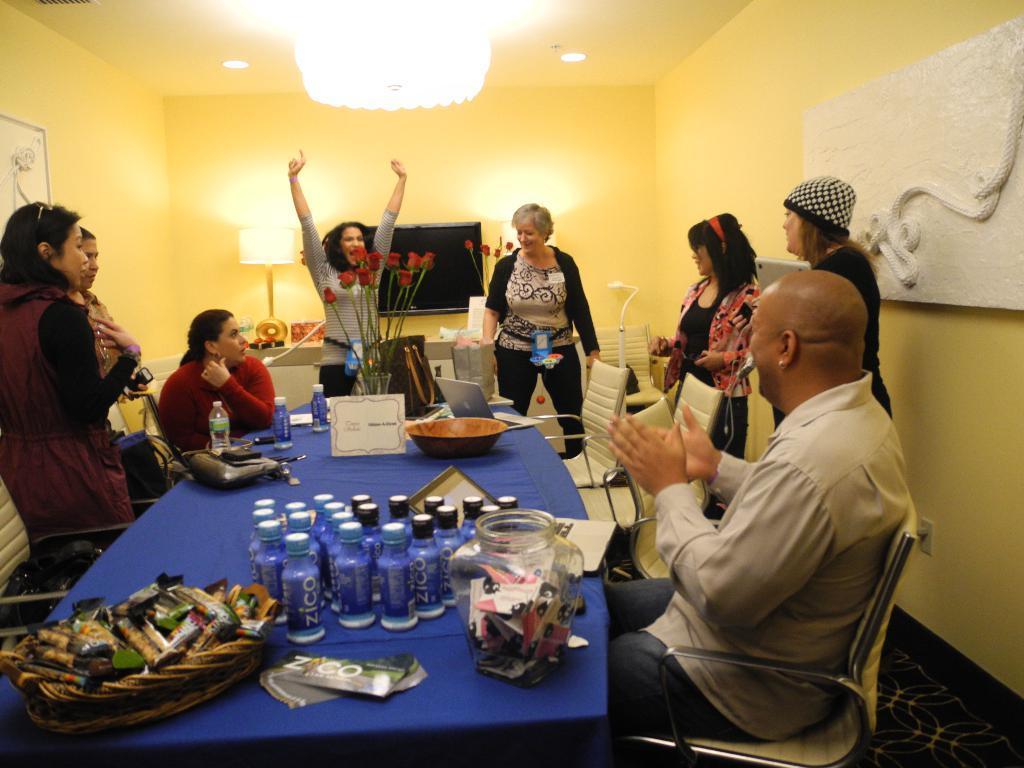Describe this image in one or two sentences. Here we can see that a group of people sitting and some are standing, and in front there is the table and some objects on it, like flowers and bottles and bag on it ,and at back there is the wall, and at the top there is the light, and here is the television, and here is the lamp. 